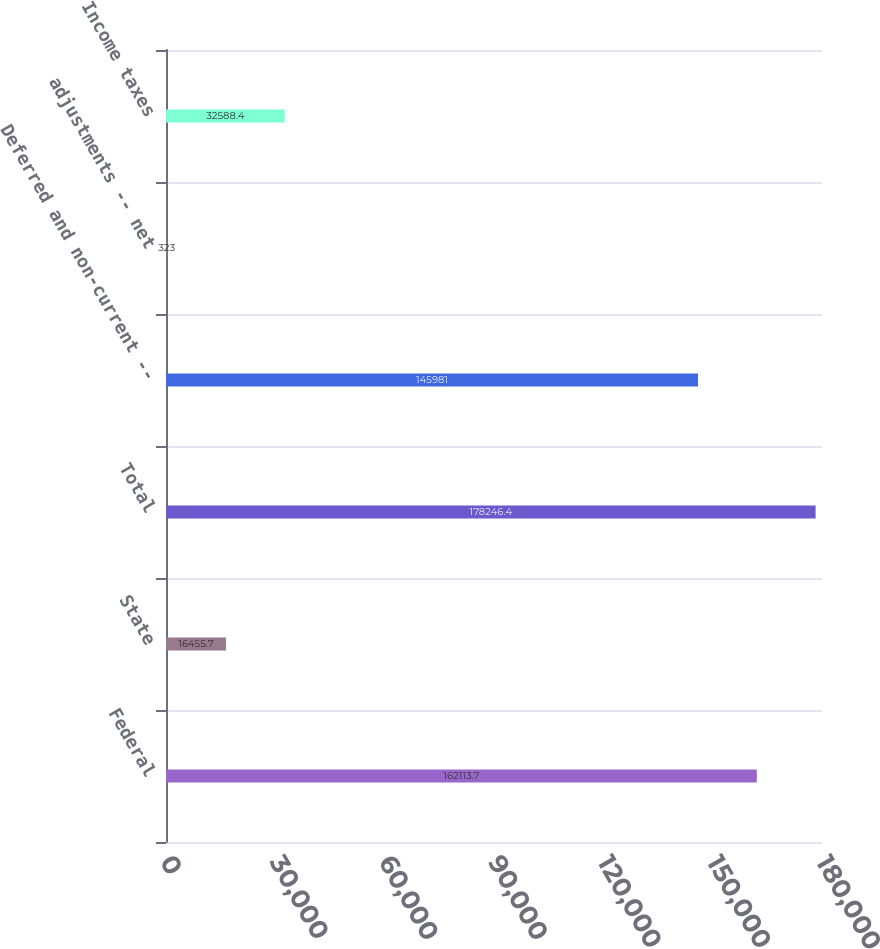<chart> <loc_0><loc_0><loc_500><loc_500><bar_chart><fcel>Federal<fcel>State<fcel>Total<fcel>Deferred and non-current --<fcel>adjustments -- net<fcel>Income taxes<nl><fcel>162114<fcel>16455.7<fcel>178246<fcel>145981<fcel>323<fcel>32588.4<nl></chart> 